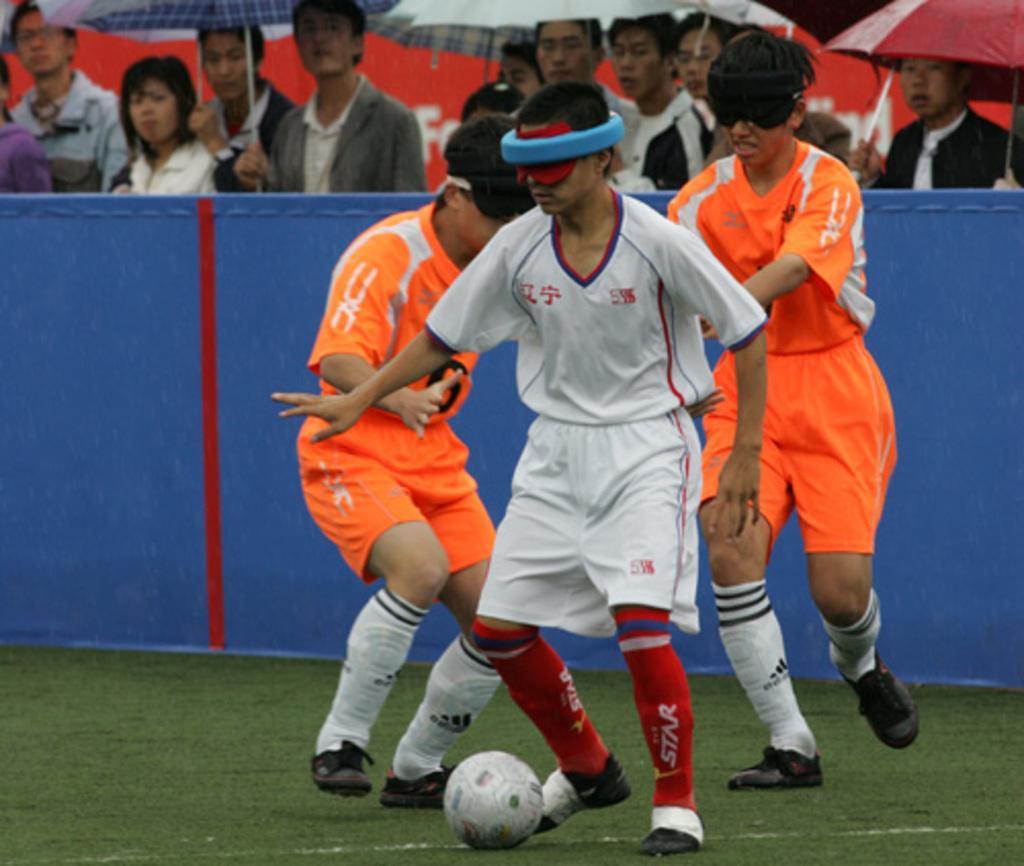How would you summarize this image in a sentence or two? In the image players are playing football. they are blindfolded. Two of the players are wearing orange jersey one is wearing white. There is a boundary around the field beside it many people are standing and watching the players. Some of them are holding umbrella. 